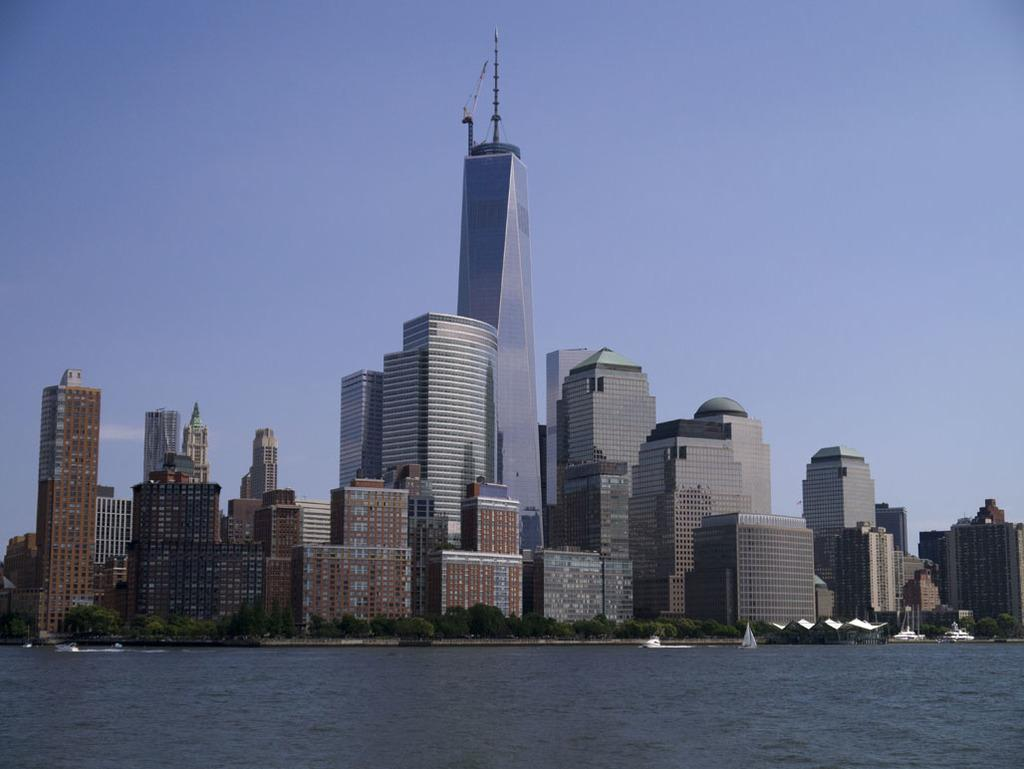What is located at the bottom of the image? There is a river at the bottom of the image. What can be seen behind the river? There are tall buildings behind the river. What type of vegetation is near the buildings? There are trees near the buildings. What is visible at the top of the image? The sky is visible at the top of the image. How many children are wearing sweaters in the image? There are no children or sweaters present in the image. What is the answer to the question that is not visible in the image? The question that is not visible in the image cannot be answered, as it is not present. 